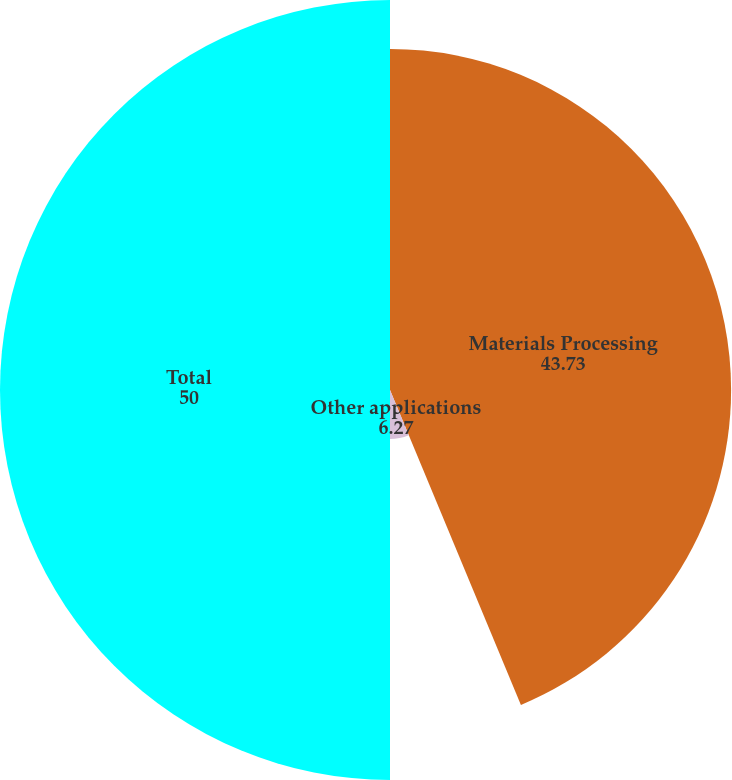Convert chart to OTSL. <chart><loc_0><loc_0><loc_500><loc_500><pie_chart><fcel>Materials Processing<fcel>Other applications<fcel>Total<nl><fcel>43.73%<fcel>6.27%<fcel>50.0%<nl></chart> 